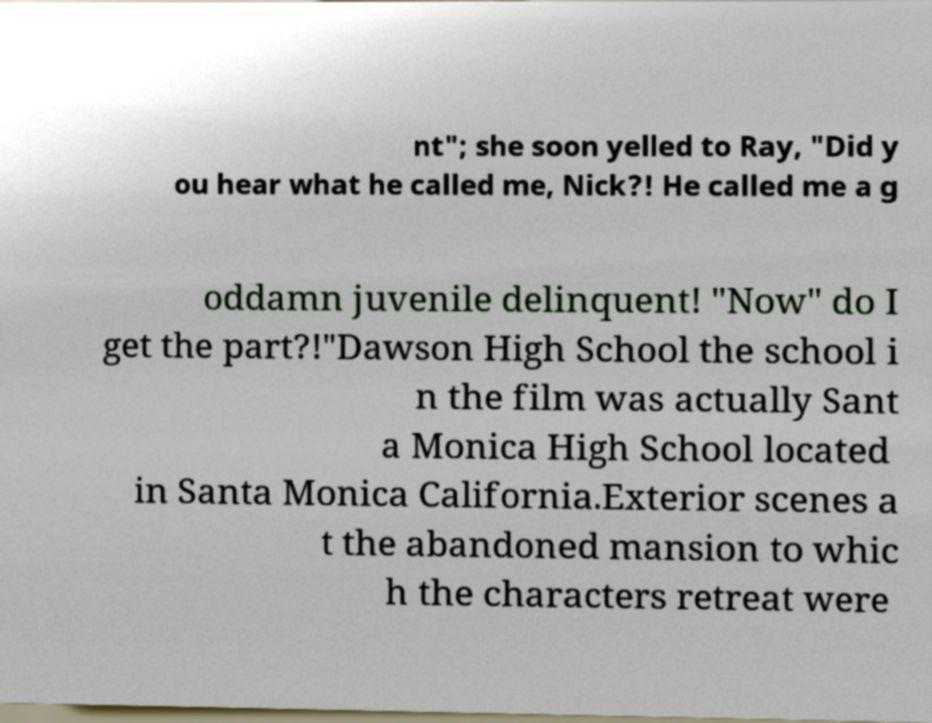Can you read and provide the text displayed in the image?This photo seems to have some interesting text. Can you extract and type it out for me? nt"; she soon yelled to Ray, "Did y ou hear what he called me, Nick?! He called me a g oddamn juvenile delinquent! "Now" do I get the part?!"Dawson High School the school i n the film was actually Sant a Monica High School located in Santa Monica California.Exterior scenes a t the abandoned mansion to whic h the characters retreat were 